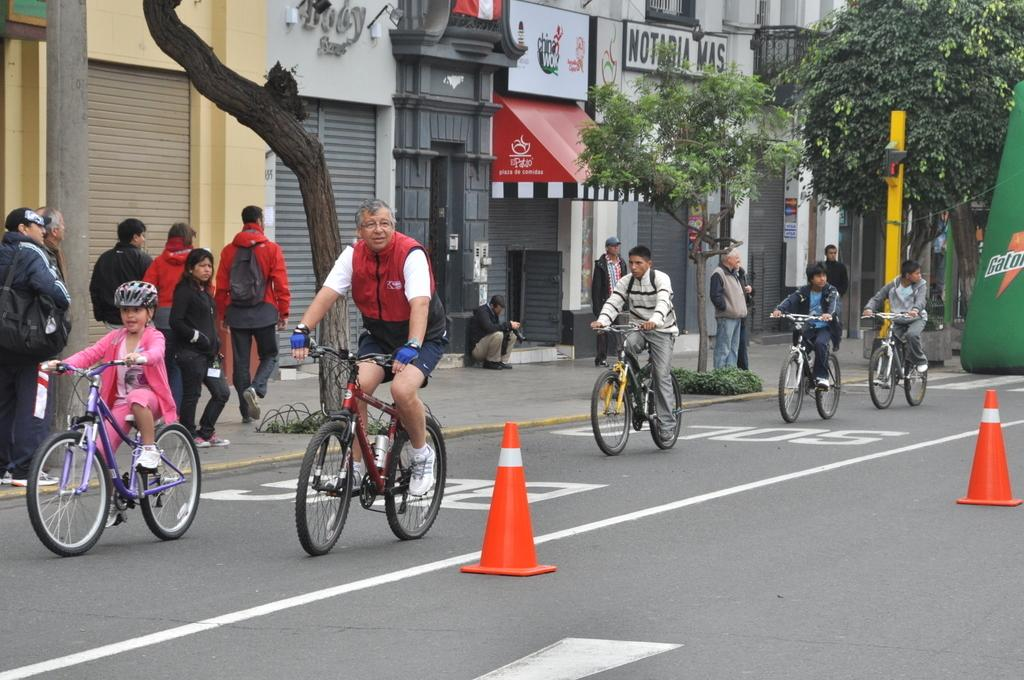What are the people in the image doing with the bicycle? The people in the image are sitting on a bicycle. What is the location of the people on the bicycle? The people on the bicycle are moving on a road. What are the people standing on in the image? The people standing on a footpath in the image. Can you hear a whistle in the image? There is no mention of a whistle in the image, so it cannot be heard. Is there a farmer in the image? There is no mention of a farmer in the image, so it cannot be determined if one is present. 